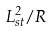Convert formula to latex. <formula><loc_0><loc_0><loc_500><loc_500>L _ { s t } ^ { 2 } / R</formula> 